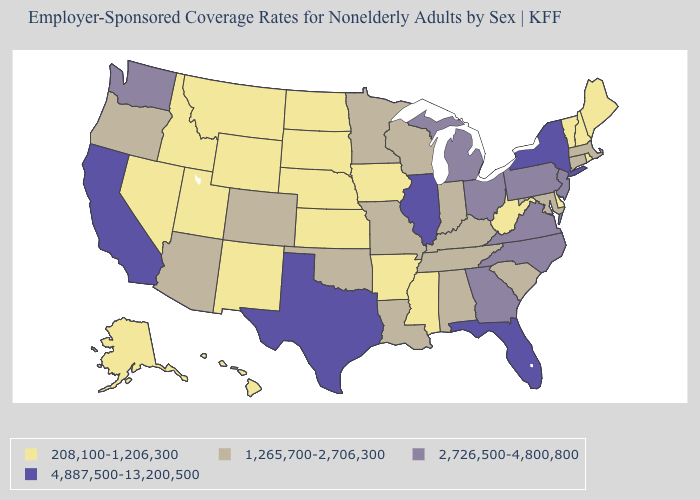What is the value of Colorado?
Quick response, please. 1,265,700-2,706,300. Name the states that have a value in the range 4,887,500-13,200,500?
Concise answer only. California, Florida, Illinois, New York, Texas. What is the value of Pennsylvania?
Quick response, please. 2,726,500-4,800,800. What is the value of Wyoming?
Answer briefly. 208,100-1,206,300. Name the states that have a value in the range 208,100-1,206,300?
Short answer required. Alaska, Arkansas, Delaware, Hawaii, Idaho, Iowa, Kansas, Maine, Mississippi, Montana, Nebraska, Nevada, New Hampshire, New Mexico, North Dakota, Rhode Island, South Dakota, Utah, Vermont, West Virginia, Wyoming. Which states hav the highest value in the MidWest?
Quick response, please. Illinois. What is the highest value in the West ?
Short answer required. 4,887,500-13,200,500. What is the value of New Hampshire?
Concise answer only. 208,100-1,206,300. What is the value of Arizona?
Answer briefly. 1,265,700-2,706,300. What is the value of Maryland?
Give a very brief answer. 1,265,700-2,706,300. Does West Virginia have the lowest value in the South?
Be succinct. Yes. Name the states that have a value in the range 208,100-1,206,300?
Be succinct. Alaska, Arkansas, Delaware, Hawaii, Idaho, Iowa, Kansas, Maine, Mississippi, Montana, Nebraska, Nevada, New Hampshire, New Mexico, North Dakota, Rhode Island, South Dakota, Utah, Vermont, West Virginia, Wyoming. Does Virginia have the lowest value in the USA?
Give a very brief answer. No. What is the lowest value in the USA?
Quick response, please. 208,100-1,206,300. What is the value of Kentucky?
Give a very brief answer. 1,265,700-2,706,300. 